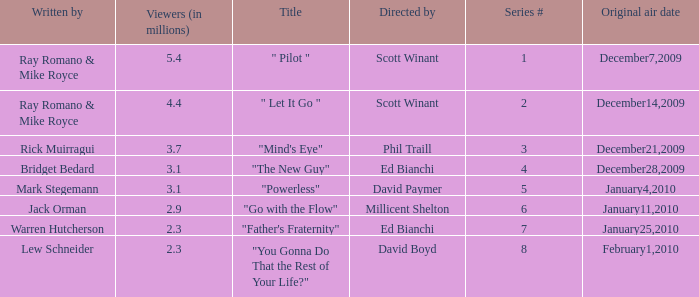What is the original air date of "Powerless"? January4,2010. 